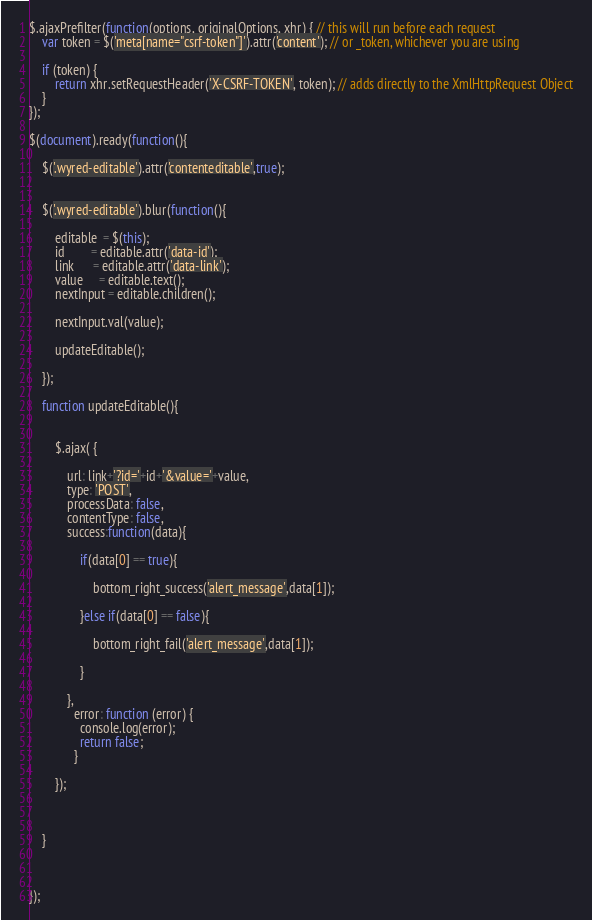Convert code to text. <code><loc_0><loc_0><loc_500><loc_500><_JavaScript_>

$.ajaxPrefilter(function(options, originalOptions, xhr) { // this will run before each request
    var token = $('meta[name="csrf-token"]').attr('content'); // or _token, whichever you are using

    if (token) {
        return xhr.setRequestHeader('X-CSRF-TOKEN', token); // adds directly to the XmlHttpRequest Object
    }
});

$(document).ready(function(){

	$('.wyred-editable').attr('contenteditable',true);


	$('.wyred-editable').blur(function(){

		editable  = $(this);
		id        = editable.attr('data-id');
		link      = editable.attr('data-link');
		value     = editable.text();
		nextInput = editable.children();

		nextInput.val(value);

		updateEditable();

	});

	function updateEditable(){


		$.ajax( {

	        url: link+'?id='+id+'&value='+value,
	        type: 'POST',
	        processData: false,
	        contentType: false,
	        success:function(data){
           
              	if(data[0] == true){

                	bottom_right_success('alert_message',data[1]);

              	}else if(data[0] == false){

                	bottom_right_fail('alert_message',data[1]);

              	}

            },
              error: function (error) {
             	console.log(error);
          		return false;
              }

        });

    	

	}



});	</code> 